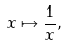<formula> <loc_0><loc_0><loc_500><loc_500>x \mapsto { \frac { 1 } { x } } ,</formula> 